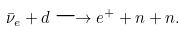Convert formula to latex. <formula><loc_0><loc_0><loc_500><loc_500>\bar { \nu } _ { e } + d \longrightarrow e ^ { + } + n + n .</formula> 